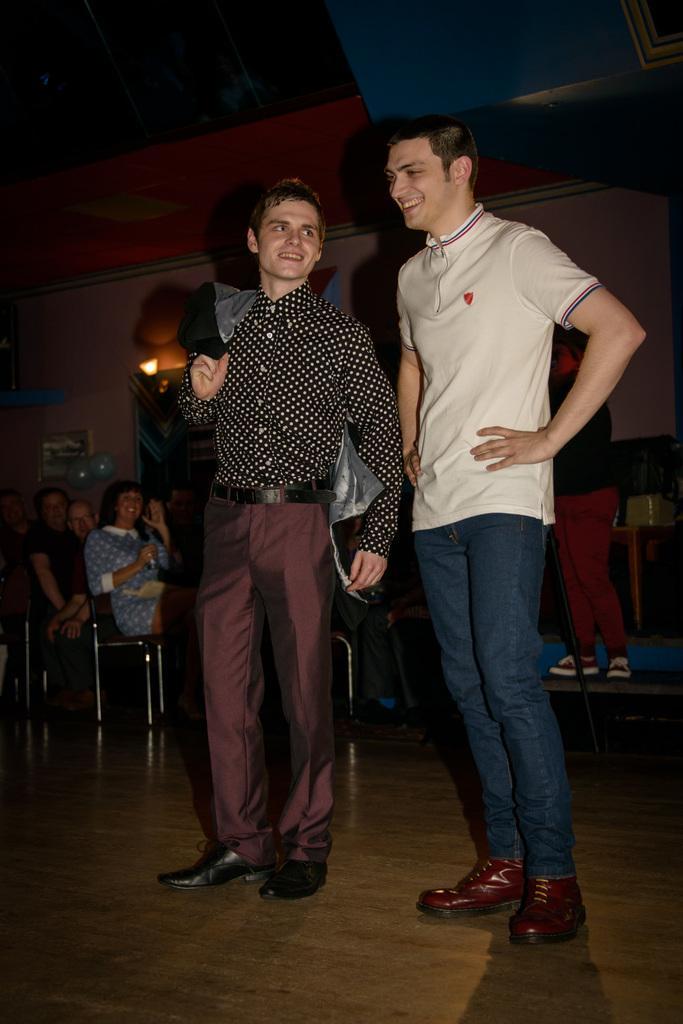Can you describe this image briefly? In this image in front there are two persons standing on the floor and they are smiling. Behind them there are a few people sitting on the chairs. There is a person standing on the stage. In the background of the image there is a wall. There is a light and there is a photo frame on the wall. 